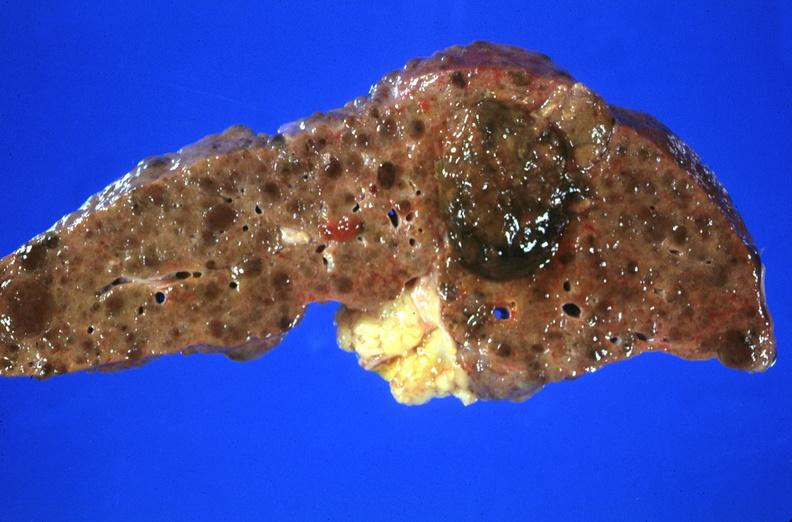s blood present?
Answer the question using a single word or phrase. No 